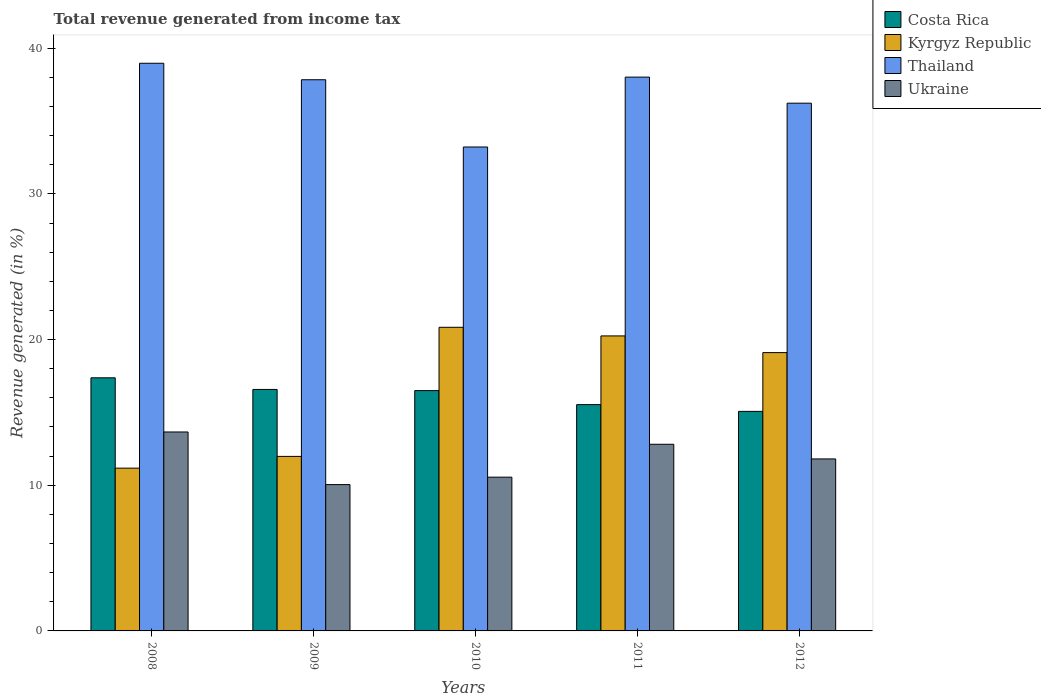How many groups of bars are there?
Ensure brevity in your answer.  5. Are the number of bars on each tick of the X-axis equal?
Give a very brief answer. Yes. How many bars are there on the 1st tick from the right?
Your response must be concise. 4. What is the label of the 5th group of bars from the left?
Offer a terse response. 2012. What is the total revenue generated in Kyrgyz Republic in 2008?
Offer a very short reply. 11.17. Across all years, what is the maximum total revenue generated in Thailand?
Give a very brief answer. 38.97. Across all years, what is the minimum total revenue generated in Costa Rica?
Offer a very short reply. 15.07. In which year was the total revenue generated in Ukraine minimum?
Ensure brevity in your answer.  2009. What is the total total revenue generated in Costa Rica in the graph?
Keep it short and to the point. 81.06. What is the difference between the total revenue generated in Thailand in 2010 and that in 2011?
Give a very brief answer. -4.8. What is the difference between the total revenue generated in Ukraine in 2011 and the total revenue generated in Thailand in 2012?
Ensure brevity in your answer.  -23.42. What is the average total revenue generated in Ukraine per year?
Offer a terse response. 11.78. In the year 2011, what is the difference between the total revenue generated in Thailand and total revenue generated in Kyrgyz Republic?
Give a very brief answer. 17.77. In how many years, is the total revenue generated in Thailand greater than 30 %?
Ensure brevity in your answer.  5. What is the ratio of the total revenue generated in Costa Rica in 2009 to that in 2010?
Provide a succinct answer. 1. Is the total revenue generated in Costa Rica in 2008 less than that in 2012?
Your response must be concise. No. Is the difference between the total revenue generated in Thailand in 2008 and 2011 greater than the difference between the total revenue generated in Kyrgyz Republic in 2008 and 2011?
Offer a very short reply. Yes. What is the difference between the highest and the second highest total revenue generated in Kyrgyz Republic?
Provide a short and direct response. 0.59. What is the difference between the highest and the lowest total revenue generated in Costa Rica?
Your response must be concise. 2.31. In how many years, is the total revenue generated in Ukraine greater than the average total revenue generated in Ukraine taken over all years?
Your answer should be compact. 3. Is the sum of the total revenue generated in Kyrgyz Republic in 2009 and 2010 greater than the maximum total revenue generated in Ukraine across all years?
Offer a terse response. Yes. What does the 2nd bar from the left in 2010 represents?
Give a very brief answer. Kyrgyz Republic. What does the 2nd bar from the right in 2010 represents?
Make the answer very short. Thailand. Is it the case that in every year, the sum of the total revenue generated in Thailand and total revenue generated in Costa Rica is greater than the total revenue generated in Ukraine?
Offer a terse response. Yes. Does the graph contain grids?
Give a very brief answer. No. Where does the legend appear in the graph?
Keep it short and to the point. Top right. How are the legend labels stacked?
Your answer should be compact. Vertical. What is the title of the graph?
Provide a short and direct response. Total revenue generated from income tax. What is the label or title of the X-axis?
Give a very brief answer. Years. What is the label or title of the Y-axis?
Provide a short and direct response. Revenue generated (in %). What is the Revenue generated (in %) of Costa Rica in 2008?
Provide a succinct answer. 17.38. What is the Revenue generated (in %) in Kyrgyz Republic in 2008?
Offer a terse response. 11.17. What is the Revenue generated (in %) of Thailand in 2008?
Offer a terse response. 38.97. What is the Revenue generated (in %) in Ukraine in 2008?
Give a very brief answer. 13.66. What is the Revenue generated (in %) of Costa Rica in 2009?
Provide a succinct answer. 16.58. What is the Revenue generated (in %) of Kyrgyz Republic in 2009?
Ensure brevity in your answer.  11.98. What is the Revenue generated (in %) in Thailand in 2009?
Provide a short and direct response. 37.84. What is the Revenue generated (in %) of Ukraine in 2009?
Provide a succinct answer. 10.05. What is the Revenue generated (in %) in Costa Rica in 2010?
Make the answer very short. 16.5. What is the Revenue generated (in %) of Kyrgyz Republic in 2010?
Provide a succinct answer. 20.84. What is the Revenue generated (in %) in Thailand in 2010?
Offer a terse response. 33.22. What is the Revenue generated (in %) of Ukraine in 2010?
Your answer should be compact. 10.56. What is the Revenue generated (in %) of Costa Rica in 2011?
Offer a terse response. 15.54. What is the Revenue generated (in %) of Kyrgyz Republic in 2011?
Your answer should be very brief. 20.25. What is the Revenue generated (in %) of Thailand in 2011?
Make the answer very short. 38.02. What is the Revenue generated (in %) of Ukraine in 2011?
Your answer should be very brief. 12.81. What is the Revenue generated (in %) in Costa Rica in 2012?
Your answer should be compact. 15.07. What is the Revenue generated (in %) of Kyrgyz Republic in 2012?
Make the answer very short. 19.11. What is the Revenue generated (in %) in Thailand in 2012?
Your answer should be compact. 36.23. What is the Revenue generated (in %) of Ukraine in 2012?
Offer a terse response. 11.81. Across all years, what is the maximum Revenue generated (in %) in Costa Rica?
Your response must be concise. 17.38. Across all years, what is the maximum Revenue generated (in %) of Kyrgyz Republic?
Your response must be concise. 20.84. Across all years, what is the maximum Revenue generated (in %) in Thailand?
Your response must be concise. 38.97. Across all years, what is the maximum Revenue generated (in %) of Ukraine?
Offer a terse response. 13.66. Across all years, what is the minimum Revenue generated (in %) of Costa Rica?
Provide a succinct answer. 15.07. Across all years, what is the minimum Revenue generated (in %) of Kyrgyz Republic?
Your answer should be compact. 11.17. Across all years, what is the minimum Revenue generated (in %) in Thailand?
Ensure brevity in your answer.  33.22. Across all years, what is the minimum Revenue generated (in %) in Ukraine?
Give a very brief answer. 10.05. What is the total Revenue generated (in %) in Costa Rica in the graph?
Provide a short and direct response. 81.06. What is the total Revenue generated (in %) in Kyrgyz Republic in the graph?
Provide a short and direct response. 83.36. What is the total Revenue generated (in %) in Thailand in the graph?
Ensure brevity in your answer.  184.28. What is the total Revenue generated (in %) of Ukraine in the graph?
Ensure brevity in your answer.  58.88. What is the difference between the Revenue generated (in %) in Costa Rica in 2008 and that in 2009?
Your response must be concise. 0.8. What is the difference between the Revenue generated (in %) in Kyrgyz Republic in 2008 and that in 2009?
Ensure brevity in your answer.  -0.81. What is the difference between the Revenue generated (in %) in Thailand in 2008 and that in 2009?
Provide a short and direct response. 1.13. What is the difference between the Revenue generated (in %) in Ukraine in 2008 and that in 2009?
Your answer should be compact. 3.61. What is the difference between the Revenue generated (in %) in Costa Rica in 2008 and that in 2010?
Ensure brevity in your answer.  0.88. What is the difference between the Revenue generated (in %) of Kyrgyz Republic in 2008 and that in 2010?
Provide a succinct answer. -9.67. What is the difference between the Revenue generated (in %) of Thailand in 2008 and that in 2010?
Your answer should be very brief. 5.75. What is the difference between the Revenue generated (in %) of Ukraine in 2008 and that in 2010?
Provide a succinct answer. 3.1. What is the difference between the Revenue generated (in %) of Costa Rica in 2008 and that in 2011?
Give a very brief answer. 1.84. What is the difference between the Revenue generated (in %) of Kyrgyz Republic in 2008 and that in 2011?
Give a very brief answer. -9.08. What is the difference between the Revenue generated (in %) of Thailand in 2008 and that in 2011?
Your answer should be compact. 0.95. What is the difference between the Revenue generated (in %) in Ukraine in 2008 and that in 2011?
Your answer should be compact. 0.84. What is the difference between the Revenue generated (in %) of Costa Rica in 2008 and that in 2012?
Provide a succinct answer. 2.31. What is the difference between the Revenue generated (in %) of Kyrgyz Republic in 2008 and that in 2012?
Your response must be concise. -7.93. What is the difference between the Revenue generated (in %) in Thailand in 2008 and that in 2012?
Make the answer very short. 2.74. What is the difference between the Revenue generated (in %) in Ukraine in 2008 and that in 2012?
Offer a terse response. 1.85. What is the difference between the Revenue generated (in %) in Costa Rica in 2009 and that in 2010?
Your response must be concise. 0.08. What is the difference between the Revenue generated (in %) of Kyrgyz Republic in 2009 and that in 2010?
Your response must be concise. -8.86. What is the difference between the Revenue generated (in %) of Thailand in 2009 and that in 2010?
Ensure brevity in your answer.  4.62. What is the difference between the Revenue generated (in %) in Ukraine in 2009 and that in 2010?
Offer a very short reply. -0.51. What is the difference between the Revenue generated (in %) of Costa Rica in 2009 and that in 2011?
Offer a very short reply. 1.04. What is the difference between the Revenue generated (in %) in Kyrgyz Republic in 2009 and that in 2011?
Make the answer very short. -8.27. What is the difference between the Revenue generated (in %) in Thailand in 2009 and that in 2011?
Make the answer very short. -0.18. What is the difference between the Revenue generated (in %) of Ukraine in 2009 and that in 2011?
Give a very brief answer. -2.77. What is the difference between the Revenue generated (in %) in Costa Rica in 2009 and that in 2012?
Provide a short and direct response. 1.51. What is the difference between the Revenue generated (in %) in Kyrgyz Republic in 2009 and that in 2012?
Make the answer very short. -7.13. What is the difference between the Revenue generated (in %) in Thailand in 2009 and that in 2012?
Your answer should be very brief. 1.61. What is the difference between the Revenue generated (in %) in Ukraine in 2009 and that in 2012?
Your response must be concise. -1.76. What is the difference between the Revenue generated (in %) of Costa Rica in 2010 and that in 2011?
Provide a succinct answer. 0.96. What is the difference between the Revenue generated (in %) of Kyrgyz Republic in 2010 and that in 2011?
Your answer should be compact. 0.59. What is the difference between the Revenue generated (in %) of Thailand in 2010 and that in 2011?
Keep it short and to the point. -4.8. What is the difference between the Revenue generated (in %) of Ukraine in 2010 and that in 2011?
Offer a very short reply. -2.26. What is the difference between the Revenue generated (in %) in Costa Rica in 2010 and that in 2012?
Your response must be concise. 1.43. What is the difference between the Revenue generated (in %) in Kyrgyz Republic in 2010 and that in 2012?
Provide a succinct answer. 1.74. What is the difference between the Revenue generated (in %) of Thailand in 2010 and that in 2012?
Give a very brief answer. -3.01. What is the difference between the Revenue generated (in %) of Ukraine in 2010 and that in 2012?
Offer a very short reply. -1.25. What is the difference between the Revenue generated (in %) in Costa Rica in 2011 and that in 2012?
Provide a short and direct response. 0.46. What is the difference between the Revenue generated (in %) in Kyrgyz Republic in 2011 and that in 2012?
Your answer should be compact. 1.15. What is the difference between the Revenue generated (in %) of Thailand in 2011 and that in 2012?
Provide a short and direct response. 1.79. What is the difference between the Revenue generated (in %) of Costa Rica in 2008 and the Revenue generated (in %) of Kyrgyz Republic in 2009?
Offer a terse response. 5.39. What is the difference between the Revenue generated (in %) of Costa Rica in 2008 and the Revenue generated (in %) of Thailand in 2009?
Your answer should be compact. -20.46. What is the difference between the Revenue generated (in %) of Costa Rica in 2008 and the Revenue generated (in %) of Ukraine in 2009?
Provide a short and direct response. 7.33. What is the difference between the Revenue generated (in %) of Kyrgyz Republic in 2008 and the Revenue generated (in %) of Thailand in 2009?
Make the answer very short. -26.66. What is the difference between the Revenue generated (in %) in Kyrgyz Republic in 2008 and the Revenue generated (in %) in Ukraine in 2009?
Keep it short and to the point. 1.13. What is the difference between the Revenue generated (in %) in Thailand in 2008 and the Revenue generated (in %) in Ukraine in 2009?
Ensure brevity in your answer.  28.93. What is the difference between the Revenue generated (in %) in Costa Rica in 2008 and the Revenue generated (in %) in Kyrgyz Republic in 2010?
Your answer should be very brief. -3.47. What is the difference between the Revenue generated (in %) of Costa Rica in 2008 and the Revenue generated (in %) of Thailand in 2010?
Offer a terse response. -15.85. What is the difference between the Revenue generated (in %) of Costa Rica in 2008 and the Revenue generated (in %) of Ukraine in 2010?
Make the answer very short. 6.82. What is the difference between the Revenue generated (in %) in Kyrgyz Republic in 2008 and the Revenue generated (in %) in Thailand in 2010?
Provide a succinct answer. -22.05. What is the difference between the Revenue generated (in %) in Kyrgyz Republic in 2008 and the Revenue generated (in %) in Ukraine in 2010?
Your answer should be compact. 0.62. What is the difference between the Revenue generated (in %) in Thailand in 2008 and the Revenue generated (in %) in Ukraine in 2010?
Your answer should be very brief. 28.41. What is the difference between the Revenue generated (in %) in Costa Rica in 2008 and the Revenue generated (in %) in Kyrgyz Republic in 2011?
Offer a terse response. -2.88. What is the difference between the Revenue generated (in %) in Costa Rica in 2008 and the Revenue generated (in %) in Thailand in 2011?
Your response must be concise. -20.64. What is the difference between the Revenue generated (in %) in Costa Rica in 2008 and the Revenue generated (in %) in Ukraine in 2011?
Ensure brevity in your answer.  4.56. What is the difference between the Revenue generated (in %) of Kyrgyz Republic in 2008 and the Revenue generated (in %) of Thailand in 2011?
Provide a succinct answer. -26.85. What is the difference between the Revenue generated (in %) in Kyrgyz Republic in 2008 and the Revenue generated (in %) in Ukraine in 2011?
Your response must be concise. -1.64. What is the difference between the Revenue generated (in %) of Thailand in 2008 and the Revenue generated (in %) of Ukraine in 2011?
Provide a short and direct response. 26.16. What is the difference between the Revenue generated (in %) of Costa Rica in 2008 and the Revenue generated (in %) of Kyrgyz Republic in 2012?
Provide a short and direct response. -1.73. What is the difference between the Revenue generated (in %) of Costa Rica in 2008 and the Revenue generated (in %) of Thailand in 2012?
Your answer should be very brief. -18.85. What is the difference between the Revenue generated (in %) of Costa Rica in 2008 and the Revenue generated (in %) of Ukraine in 2012?
Your answer should be compact. 5.57. What is the difference between the Revenue generated (in %) in Kyrgyz Republic in 2008 and the Revenue generated (in %) in Thailand in 2012?
Give a very brief answer. -25.06. What is the difference between the Revenue generated (in %) of Kyrgyz Republic in 2008 and the Revenue generated (in %) of Ukraine in 2012?
Ensure brevity in your answer.  -0.63. What is the difference between the Revenue generated (in %) in Thailand in 2008 and the Revenue generated (in %) in Ukraine in 2012?
Offer a very short reply. 27.16. What is the difference between the Revenue generated (in %) of Costa Rica in 2009 and the Revenue generated (in %) of Kyrgyz Republic in 2010?
Provide a short and direct response. -4.27. What is the difference between the Revenue generated (in %) of Costa Rica in 2009 and the Revenue generated (in %) of Thailand in 2010?
Offer a terse response. -16.65. What is the difference between the Revenue generated (in %) in Costa Rica in 2009 and the Revenue generated (in %) in Ukraine in 2010?
Give a very brief answer. 6.02. What is the difference between the Revenue generated (in %) in Kyrgyz Republic in 2009 and the Revenue generated (in %) in Thailand in 2010?
Provide a succinct answer. -21.24. What is the difference between the Revenue generated (in %) of Kyrgyz Republic in 2009 and the Revenue generated (in %) of Ukraine in 2010?
Your response must be concise. 1.43. What is the difference between the Revenue generated (in %) in Thailand in 2009 and the Revenue generated (in %) in Ukraine in 2010?
Your answer should be very brief. 27.28. What is the difference between the Revenue generated (in %) in Costa Rica in 2009 and the Revenue generated (in %) in Kyrgyz Republic in 2011?
Offer a very short reply. -3.68. What is the difference between the Revenue generated (in %) in Costa Rica in 2009 and the Revenue generated (in %) in Thailand in 2011?
Your answer should be very brief. -21.44. What is the difference between the Revenue generated (in %) of Costa Rica in 2009 and the Revenue generated (in %) of Ukraine in 2011?
Your answer should be very brief. 3.76. What is the difference between the Revenue generated (in %) of Kyrgyz Republic in 2009 and the Revenue generated (in %) of Thailand in 2011?
Your answer should be very brief. -26.04. What is the difference between the Revenue generated (in %) of Kyrgyz Republic in 2009 and the Revenue generated (in %) of Ukraine in 2011?
Provide a succinct answer. -0.83. What is the difference between the Revenue generated (in %) in Thailand in 2009 and the Revenue generated (in %) in Ukraine in 2011?
Your answer should be compact. 25.02. What is the difference between the Revenue generated (in %) of Costa Rica in 2009 and the Revenue generated (in %) of Kyrgyz Republic in 2012?
Give a very brief answer. -2.53. What is the difference between the Revenue generated (in %) in Costa Rica in 2009 and the Revenue generated (in %) in Thailand in 2012?
Provide a succinct answer. -19.65. What is the difference between the Revenue generated (in %) in Costa Rica in 2009 and the Revenue generated (in %) in Ukraine in 2012?
Make the answer very short. 4.77. What is the difference between the Revenue generated (in %) in Kyrgyz Republic in 2009 and the Revenue generated (in %) in Thailand in 2012?
Your response must be concise. -24.25. What is the difference between the Revenue generated (in %) of Kyrgyz Republic in 2009 and the Revenue generated (in %) of Ukraine in 2012?
Make the answer very short. 0.17. What is the difference between the Revenue generated (in %) in Thailand in 2009 and the Revenue generated (in %) in Ukraine in 2012?
Ensure brevity in your answer.  26.03. What is the difference between the Revenue generated (in %) of Costa Rica in 2010 and the Revenue generated (in %) of Kyrgyz Republic in 2011?
Provide a short and direct response. -3.76. What is the difference between the Revenue generated (in %) of Costa Rica in 2010 and the Revenue generated (in %) of Thailand in 2011?
Give a very brief answer. -21.52. What is the difference between the Revenue generated (in %) in Costa Rica in 2010 and the Revenue generated (in %) in Ukraine in 2011?
Your answer should be very brief. 3.68. What is the difference between the Revenue generated (in %) of Kyrgyz Republic in 2010 and the Revenue generated (in %) of Thailand in 2011?
Give a very brief answer. -17.18. What is the difference between the Revenue generated (in %) in Kyrgyz Republic in 2010 and the Revenue generated (in %) in Ukraine in 2011?
Give a very brief answer. 8.03. What is the difference between the Revenue generated (in %) of Thailand in 2010 and the Revenue generated (in %) of Ukraine in 2011?
Offer a terse response. 20.41. What is the difference between the Revenue generated (in %) of Costa Rica in 2010 and the Revenue generated (in %) of Kyrgyz Republic in 2012?
Offer a very short reply. -2.61. What is the difference between the Revenue generated (in %) in Costa Rica in 2010 and the Revenue generated (in %) in Thailand in 2012?
Your response must be concise. -19.73. What is the difference between the Revenue generated (in %) in Costa Rica in 2010 and the Revenue generated (in %) in Ukraine in 2012?
Make the answer very short. 4.69. What is the difference between the Revenue generated (in %) of Kyrgyz Republic in 2010 and the Revenue generated (in %) of Thailand in 2012?
Give a very brief answer. -15.39. What is the difference between the Revenue generated (in %) of Kyrgyz Republic in 2010 and the Revenue generated (in %) of Ukraine in 2012?
Your answer should be compact. 9.04. What is the difference between the Revenue generated (in %) of Thailand in 2010 and the Revenue generated (in %) of Ukraine in 2012?
Offer a terse response. 21.41. What is the difference between the Revenue generated (in %) of Costa Rica in 2011 and the Revenue generated (in %) of Kyrgyz Republic in 2012?
Give a very brief answer. -3.57. What is the difference between the Revenue generated (in %) of Costa Rica in 2011 and the Revenue generated (in %) of Thailand in 2012?
Provide a short and direct response. -20.69. What is the difference between the Revenue generated (in %) of Costa Rica in 2011 and the Revenue generated (in %) of Ukraine in 2012?
Provide a succinct answer. 3.73. What is the difference between the Revenue generated (in %) of Kyrgyz Republic in 2011 and the Revenue generated (in %) of Thailand in 2012?
Your response must be concise. -15.98. What is the difference between the Revenue generated (in %) in Kyrgyz Republic in 2011 and the Revenue generated (in %) in Ukraine in 2012?
Give a very brief answer. 8.45. What is the difference between the Revenue generated (in %) in Thailand in 2011 and the Revenue generated (in %) in Ukraine in 2012?
Make the answer very short. 26.21. What is the average Revenue generated (in %) in Costa Rica per year?
Your answer should be very brief. 16.21. What is the average Revenue generated (in %) in Kyrgyz Republic per year?
Provide a succinct answer. 16.67. What is the average Revenue generated (in %) of Thailand per year?
Keep it short and to the point. 36.86. What is the average Revenue generated (in %) of Ukraine per year?
Offer a terse response. 11.78. In the year 2008, what is the difference between the Revenue generated (in %) in Costa Rica and Revenue generated (in %) in Kyrgyz Republic?
Provide a short and direct response. 6.2. In the year 2008, what is the difference between the Revenue generated (in %) of Costa Rica and Revenue generated (in %) of Thailand?
Your response must be concise. -21.59. In the year 2008, what is the difference between the Revenue generated (in %) in Costa Rica and Revenue generated (in %) in Ukraine?
Ensure brevity in your answer.  3.72. In the year 2008, what is the difference between the Revenue generated (in %) in Kyrgyz Republic and Revenue generated (in %) in Thailand?
Keep it short and to the point. -27.8. In the year 2008, what is the difference between the Revenue generated (in %) in Kyrgyz Republic and Revenue generated (in %) in Ukraine?
Your answer should be compact. -2.48. In the year 2008, what is the difference between the Revenue generated (in %) in Thailand and Revenue generated (in %) in Ukraine?
Your response must be concise. 25.31. In the year 2009, what is the difference between the Revenue generated (in %) in Costa Rica and Revenue generated (in %) in Kyrgyz Republic?
Make the answer very short. 4.6. In the year 2009, what is the difference between the Revenue generated (in %) in Costa Rica and Revenue generated (in %) in Thailand?
Keep it short and to the point. -21.26. In the year 2009, what is the difference between the Revenue generated (in %) in Costa Rica and Revenue generated (in %) in Ukraine?
Keep it short and to the point. 6.53. In the year 2009, what is the difference between the Revenue generated (in %) in Kyrgyz Republic and Revenue generated (in %) in Thailand?
Your answer should be very brief. -25.86. In the year 2009, what is the difference between the Revenue generated (in %) of Kyrgyz Republic and Revenue generated (in %) of Ukraine?
Provide a short and direct response. 1.94. In the year 2009, what is the difference between the Revenue generated (in %) of Thailand and Revenue generated (in %) of Ukraine?
Keep it short and to the point. 27.79. In the year 2010, what is the difference between the Revenue generated (in %) of Costa Rica and Revenue generated (in %) of Kyrgyz Republic?
Give a very brief answer. -4.35. In the year 2010, what is the difference between the Revenue generated (in %) in Costa Rica and Revenue generated (in %) in Thailand?
Provide a short and direct response. -16.72. In the year 2010, what is the difference between the Revenue generated (in %) in Costa Rica and Revenue generated (in %) in Ukraine?
Your answer should be very brief. 5.94. In the year 2010, what is the difference between the Revenue generated (in %) of Kyrgyz Republic and Revenue generated (in %) of Thailand?
Make the answer very short. -12.38. In the year 2010, what is the difference between the Revenue generated (in %) of Kyrgyz Republic and Revenue generated (in %) of Ukraine?
Ensure brevity in your answer.  10.29. In the year 2010, what is the difference between the Revenue generated (in %) of Thailand and Revenue generated (in %) of Ukraine?
Provide a short and direct response. 22.67. In the year 2011, what is the difference between the Revenue generated (in %) of Costa Rica and Revenue generated (in %) of Kyrgyz Republic?
Give a very brief answer. -4.72. In the year 2011, what is the difference between the Revenue generated (in %) of Costa Rica and Revenue generated (in %) of Thailand?
Keep it short and to the point. -22.48. In the year 2011, what is the difference between the Revenue generated (in %) of Costa Rica and Revenue generated (in %) of Ukraine?
Ensure brevity in your answer.  2.72. In the year 2011, what is the difference between the Revenue generated (in %) in Kyrgyz Republic and Revenue generated (in %) in Thailand?
Ensure brevity in your answer.  -17.77. In the year 2011, what is the difference between the Revenue generated (in %) in Kyrgyz Republic and Revenue generated (in %) in Ukraine?
Your response must be concise. 7.44. In the year 2011, what is the difference between the Revenue generated (in %) of Thailand and Revenue generated (in %) of Ukraine?
Your answer should be very brief. 25.21. In the year 2012, what is the difference between the Revenue generated (in %) of Costa Rica and Revenue generated (in %) of Kyrgyz Republic?
Offer a very short reply. -4.04. In the year 2012, what is the difference between the Revenue generated (in %) in Costa Rica and Revenue generated (in %) in Thailand?
Give a very brief answer. -21.16. In the year 2012, what is the difference between the Revenue generated (in %) of Costa Rica and Revenue generated (in %) of Ukraine?
Give a very brief answer. 3.26. In the year 2012, what is the difference between the Revenue generated (in %) in Kyrgyz Republic and Revenue generated (in %) in Thailand?
Your answer should be very brief. -17.12. In the year 2012, what is the difference between the Revenue generated (in %) in Kyrgyz Republic and Revenue generated (in %) in Ukraine?
Provide a short and direct response. 7.3. In the year 2012, what is the difference between the Revenue generated (in %) of Thailand and Revenue generated (in %) of Ukraine?
Make the answer very short. 24.42. What is the ratio of the Revenue generated (in %) in Costa Rica in 2008 to that in 2009?
Your response must be concise. 1.05. What is the ratio of the Revenue generated (in %) in Kyrgyz Republic in 2008 to that in 2009?
Ensure brevity in your answer.  0.93. What is the ratio of the Revenue generated (in %) of Thailand in 2008 to that in 2009?
Give a very brief answer. 1.03. What is the ratio of the Revenue generated (in %) in Ukraine in 2008 to that in 2009?
Give a very brief answer. 1.36. What is the ratio of the Revenue generated (in %) in Costa Rica in 2008 to that in 2010?
Make the answer very short. 1.05. What is the ratio of the Revenue generated (in %) in Kyrgyz Republic in 2008 to that in 2010?
Your response must be concise. 0.54. What is the ratio of the Revenue generated (in %) in Thailand in 2008 to that in 2010?
Provide a succinct answer. 1.17. What is the ratio of the Revenue generated (in %) in Ukraine in 2008 to that in 2010?
Offer a very short reply. 1.29. What is the ratio of the Revenue generated (in %) in Costa Rica in 2008 to that in 2011?
Give a very brief answer. 1.12. What is the ratio of the Revenue generated (in %) of Kyrgyz Republic in 2008 to that in 2011?
Ensure brevity in your answer.  0.55. What is the ratio of the Revenue generated (in %) of Ukraine in 2008 to that in 2011?
Ensure brevity in your answer.  1.07. What is the ratio of the Revenue generated (in %) of Costa Rica in 2008 to that in 2012?
Give a very brief answer. 1.15. What is the ratio of the Revenue generated (in %) of Kyrgyz Republic in 2008 to that in 2012?
Your answer should be compact. 0.58. What is the ratio of the Revenue generated (in %) of Thailand in 2008 to that in 2012?
Ensure brevity in your answer.  1.08. What is the ratio of the Revenue generated (in %) of Ukraine in 2008 to that in 2012?
Offer a very short reply. 1.16. What is the ratio of the Revenue generated (in %) in Costa Rica in 2009 to that in 2010?
Your response must be concise. 1. What is the ratio of the Revenue generated (in %) in Kyrgyz Republic in 2009 to that in 2010?
Offer a terse response. 0.57. What is the ratio of the Revenue generated (in %) in Thailand in 2009 to that in 2010?
Ensure brevity in your answer.  1.14. What is the ratio of the Revenue generated (in %) in Ukraine in 2009 to that in 2010?
Provide a succinct answer. 0.95. What is the ratio of the Revenue generated (in %) of Costa Rica in 2009 to that in 2011?
Give a very brief answer. 1.07. What is the ratio of the Revenue generated (in %) in Kyrgyz Republic in 2009 to that in 2011?
Keep it short and to the point. 0.59. What is the ratio of the Revenue generated (in %) of Thailand in 2009 to that in 2011?
Ensure brevity in your answer.  1. What is the ratio of the Revenue generated (in %) in Ukraine in 2009 to that in 2011?
Make the answer very short. 0.78. What is the ratio of the Revenue generated (in %) of Costa Rica in 2009 to that in 2012?
Provide a short and direct response. 1.1. What is the ratio of the Revenue generated (in %) in Kyrgyz Republic in 2009 to that in 2012?
Offer a very short reply. 0.63. What is the ratio of the Revenue generated (in %) of Thailand in 2009 to that in 2012?
Your answer should be very brief. 1.04. What is the ratio of the Revenue generated (in %) in Ukraine in 2009 to that in 2012?
Your answer should be very brief. 0.85. What is the ratio of the Revenue generated (in %) of Costa Rica in 2010 to that in 2011?
Provide a short and direct response. 1.06. What is the ratio of the Revenue generated (in %) of Kyrgyz Republic in 2010 to that in 2011?
Offer a very short reply. 1.03. What is the ratio of the Revenue generated (in %) in Thailand in 2010 to that in 2011?
Give a very brief answer. 0.87. What is the ratio of the Revenue generated (in %) of Ukraine in 2010 to that in 2011?
Provide a succinct answer. 0.82. What is the ratio of the Revenue generated (in %) in Costa Rica in 2010 to that in 2012?
Your answer should be compact. 1.09. What is the ratio of the Revenue generated (in %) in Kyrgyz Republic in 2010 to that in 2012?
Offer a very short reply. 1.09. What is the ratio of the Revenue generated (in %) in Thailand in 2010 to that in 2012?
Provide a short and direct response. 0.92. What is the ratio of the Revenue generated (in %) of Ukraine in 2010 to that in 2012?
Make the answer very short. 0.89. What is the ratio of the Revenue generated (in %) of Costa Rica in 2011 to that in 2012?
Your response must be concise. 1.03. What is the ratio of the Revenue generated (in %) in Kyrgyz Republic in 2011 to that in 2012?
Offer a terse response. 1.06. What is the ratio of the Revenue generated (in %) of Thailand in 2011 to that in 2012?
Provide a short and direct response. 1.05. What is the ratio of the Revenue generated (in %) of Ukraine in 2011 to that in 2012?
Your answer should be compact. 1.09. What is the difference between the highest and the second highest Revenue generated (in %) of Costa Rica?
Ensure brevity in your answer.  0.8. What is the difference between the highest and the second highest Revenue generated (in %) of Kyrgyz Republic?
Offer a terse response. 0.59. What is the difference between the highest and the second highest Revenue generated (in %) in Thailand?
Ensure brevity in your answer.  0.95. What is the difference between the highest and the second highest Revenue generated (in %) of Ukraine?
Offer a terse response. 0.84. What is the difference between the highest and the lowest Revenue generated (in %) in Costa Rica?
Ensure brevity in your answer.  2.31. What is the difference between the highest and the lowest Revenue generated (in %) in Kyrgyz Republic?
Give a very brief answer. 9.67. What is the difference between the highest and the lowest Revenue generated (in %) of Thailand?
Offer a very short reply. 5.75. What is the difference between the highest and the lowest Revenue generated (in %) of Ukraine?
Your answer should be compact. 3.61. 